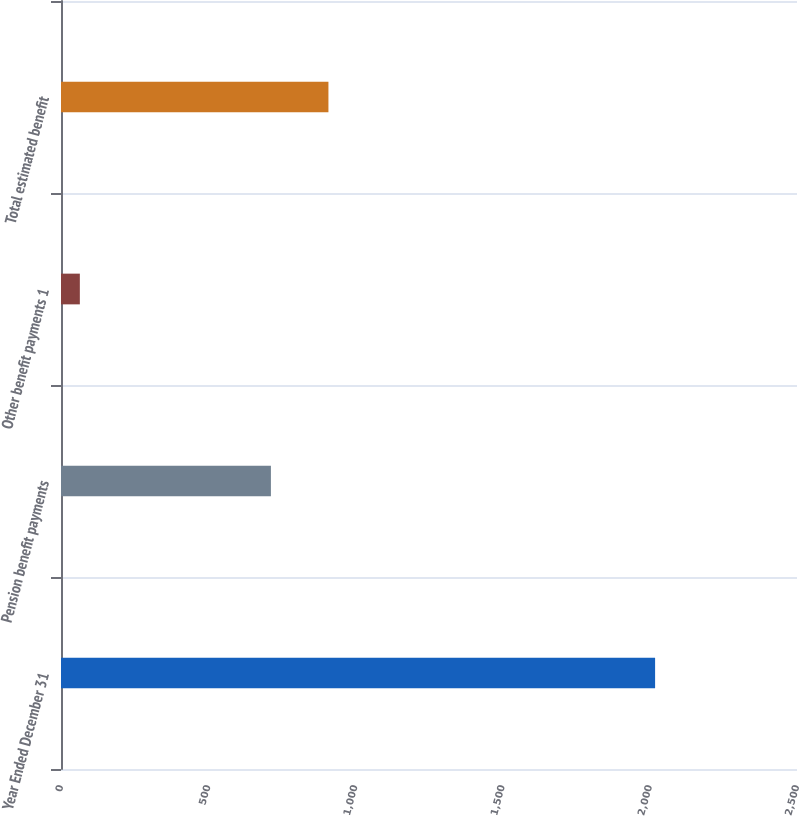Convert chart to OTSL. <chart><loc_0><loc_0><loc_500><loc_500><bar_chart><fcel>Year Ended December 31<fcel>Pension benefit payments<fcel>Other benefit payments 1<fcel>Total estimated benefit<nl><fcel>2018<fcel>713<fcel>64<fcel>908.4<nl></chart> 